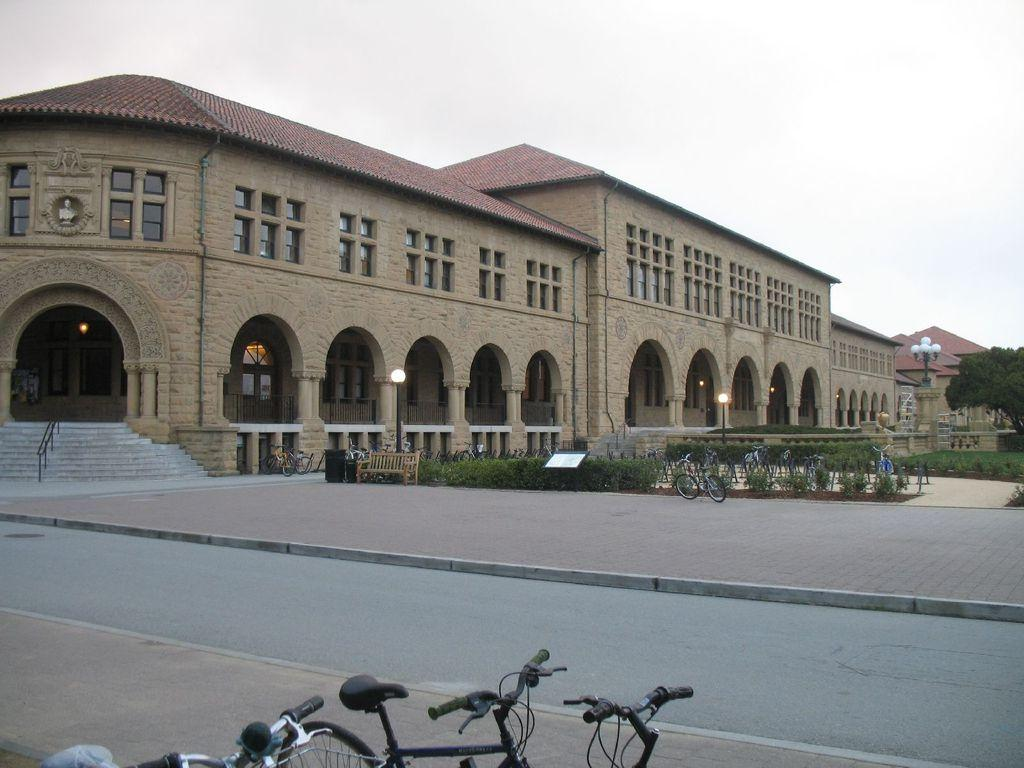What type of structure can be seen in the image? There is a building in the image. What can be seen above the building in the image? There is sky visible in the image. What type of seating is present in the image? There is a bench in the image. What is the source of illumination in the image? There is light in the image. What type of vegetation is present in the image? There are plants in the image. What type of transportation can be seen in the image? There are bicycles parked in the image. How can one access different levels of the building in the image? There are staircases in the image. What type of school can be seen in the image? There is no school present in the image; it features a building with other elements like a bench, bicycles, and staircases. What is the middle of the image showing? The provided facts do not specify a "middle" of the image, so it's not possible to answer this question definitively. 